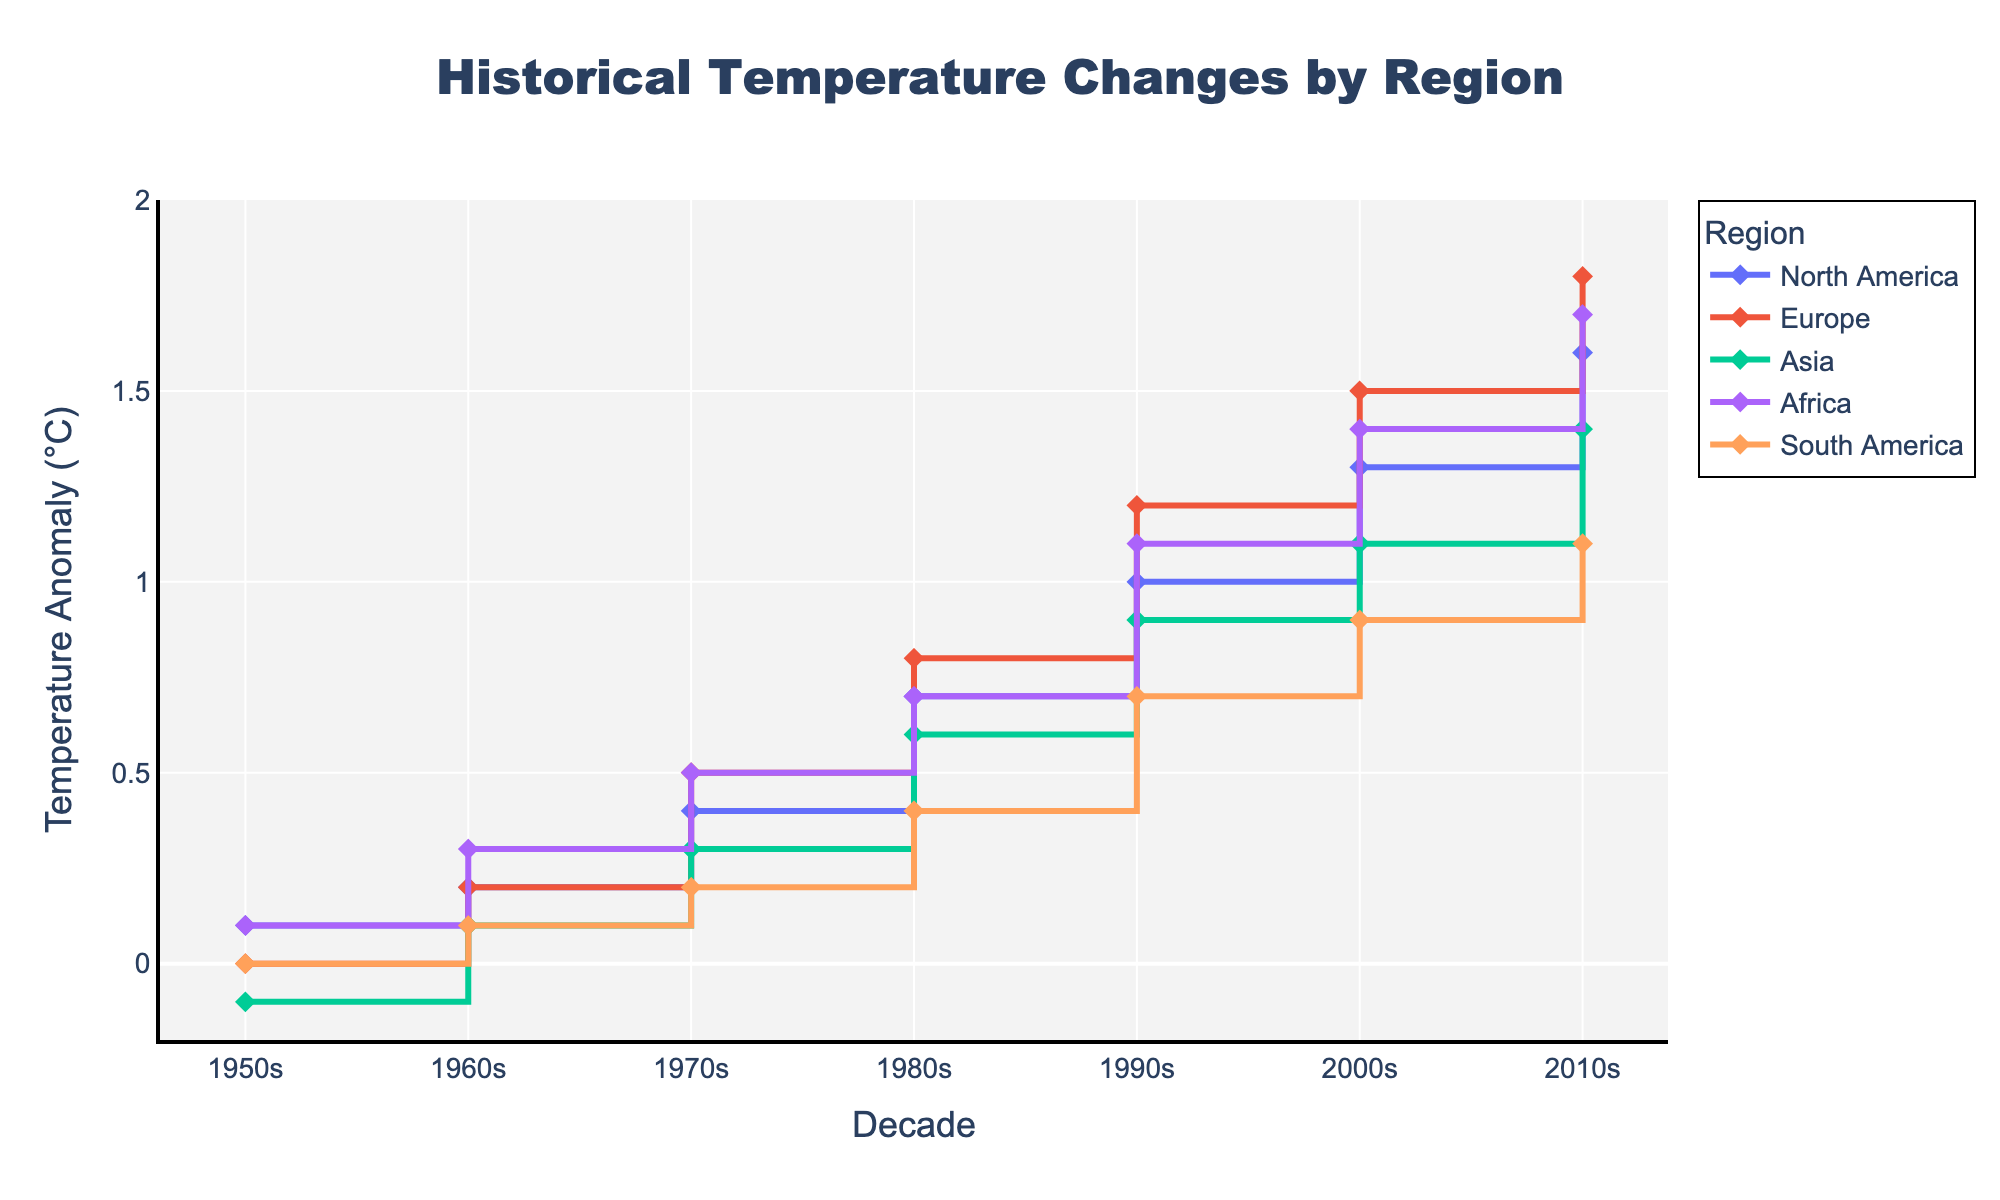What's the title of the figure? The title of the figure is typically displayed at the top-center of the plot. By observing, the title is clearly shown in bold larger font compared to other text elements.
Answer: Historical Temperature Changes by Region Which region experienced the highest temperature anomaly in the 2010s? From the stair plot, the temperature anomalies for each region in the 2010s are marked by a data point at the end of each region's line. By comparing these points, Africa has the highest anomaly.
Answer: Africa By how much did the temperature anomaly change in Asia from the 1950s to the 2010s? The temperature anomaly for Asia in the 1950s is indicated as -0.1°C and in the 2010s as 1.4°C. Subtracting these values gives: 1.4 - (-0.1) = 1.5°C.
Answer: 1.5°C How did the temperature anomaly in Europe change from the 1980s to the 1990s? In the 1980s, Europe's temperature anomaly is 0.8°C and in the 1990s, it is 1.2°C. The change is calculated by subtracting the 1980s value from the 1990s value: 1.2 - 0.8 = 0.4°C.
Answer: 0.4°C Compare the temperature anomalies of North America and South America in the 2000s. Which region had a higher temperature anomaly? In the stair plot for the 2000s, the temperature anomalies are: North America - 1.3°C, South America - 0.9°C. North America had a higher temperature anomaly.
Answer: North America What is the average temperature anomaly for Africa across all decades? The temperature anomalies for Africa across all decades are: 0.1, 0.3, 0.5, 0.7, 1.1, 1.4, 1.7. Summing these values: 0.1 + 0.3 + 0.5 + 0.7 + 1.1 + 1.4 + 1.7 = 5.8. The number of decades is 7, so the average is 5.8 / 7 ≈ 0.83.
Answer: 0.83°C 